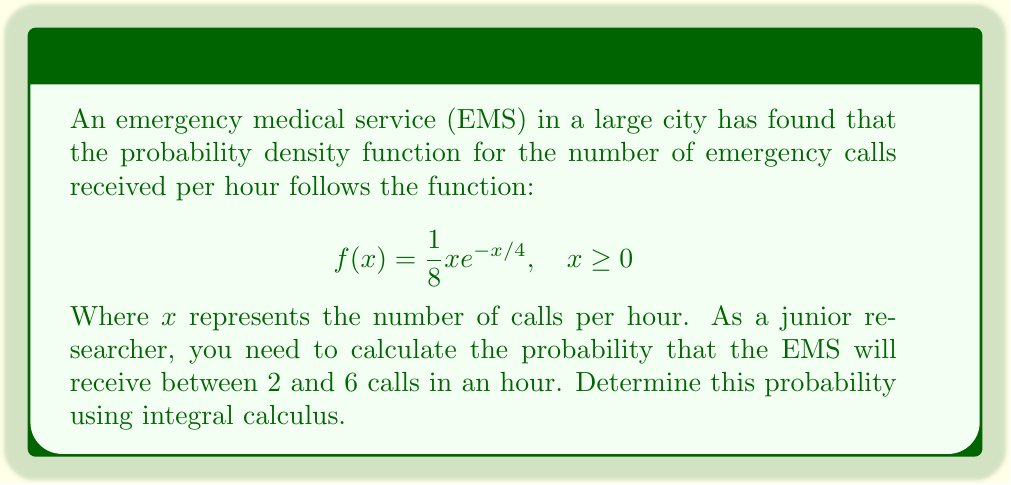Can you answer this question? To solve this problem, we need to integrate the probability density function over the given interval. Here's the step-by-step solution:

1) The probability of receiving between 2 and 6 calls in an hour is given by the integral:

   $$P(2 \leq X \leq 6) = \int_2^6 f(x) dx = \int_2^6 \frac{1}{8}xe^{-x/4} dx$$

2) To evaluate this integral, we can use integration by parts. Let:
   $u = x$ and $dv = \frac{1}{8}e^{-x/4} dx$

   Then: $du = dx$ and $v = -\frac{1}{2}e^{-x/4}$

3) Applying integration by parts formula:

   $$\int_2^6 \frac{1}{8}xe^{-x/4} dx = [-\frac{1}{2}xe^{-x/4}]_2^6 + \int_2^6 \frac{1}{2}e^{-x/4} dx$$

4) Evaluate the first term:

   $$[-\frac{1}{2}xe^{-x/4}]_2^6 = -3e^{-3/2} + e^{-1/2}$$

5) For the second integral, integrate:

   $$\int_2^6 \frac{1}{2}e^{-x/4} dx = [-2e^{-x/4}]_2^6 = -2e^{-3/2} + 2e^{-1/2}$$

6) Combining the results:

   $$P(2 \leq X \leq 6) = (-3e^{-3/2} + e^{-1/2}) + (-2e^{-3/2} + 2e^{-1/2})$$
   $$= -5e^{-3/2} + 3e^{-1/2}$$

7) Calculate the final value:

   $$P(2 \leq X \leq 6) \approx 0.3233$$

Therefore, the probability that the EMS will receive between 2 and 6 calls in an hour is approximately 0.3233 or 32.33%.
Answer: $0.3233$ or $32.33\%$ 